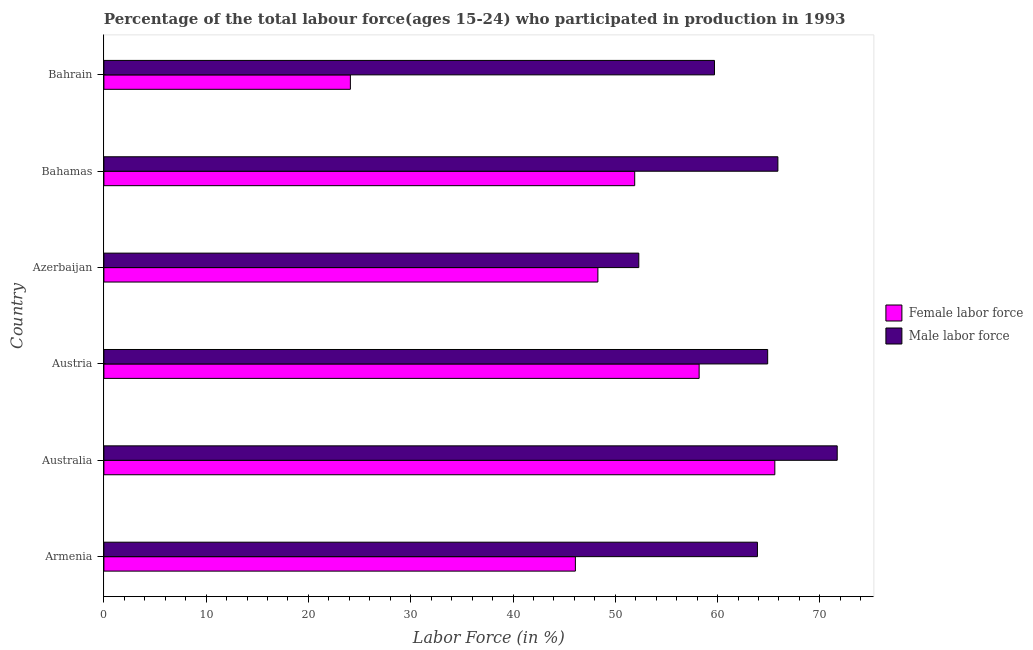How many different coloured bars are there?
Give a very brief answer. 2. What is the label of the 6th group of bars from the top?
Your answer should be compact. Armenia. In how many cases, is the number of bars for a given country not equal to the number of legend labels?
Your answer should be compact. 0. What is the percentage of female labor force in Armenia?
Give a very brief answer. 46.1. Across all countries, what is the maximum percentage of female labor force?
Make the answer very short. 65.6. Across all countries, what is the minimum percentage of male labour force?
Your response must be concise. 52.3. In which country was the percentage of male labour force minimum?
Offer a very short reply. Azerbaijan. What is the total percentage of female labor force in the graph?
Provide a short and direct response. 294.2. What is the difference between the percentage of male labour force in Australia and the percentage of female labor force in Bahrain?
Your answer should be compact. 47.6. What is the average percentage of female labor force per country?
Offer a terse response. 49.03. What is the difference between the percentage of female labor force and percentage of male labour force in Bahrain?
Make the answer very short. -35.6. What is the ratio of the percentage of male labour force in Austria to that in Azerbaijan?
Offer a terse response. 1.24. What is the difference between the highest and the second highest percentage of male labour force?
Provide a succinct answer. 5.8. What is the difference between the highest and the lowest percentage of male labour force?
Provide a succinct answer. 19.4. Is the sum of the percentage of female labor force in Bahamas and Bahrain greater than the maximum percentage of male labour force across all countries?
Give a very brief answer. Yes. What does the 1st bar from the top in Bahamas represents?
Ensure brevity in your answer.  Male labor force. What does the 1st bar from the bottom in Azerbaijan represents?
Ensure brevity in your answer.  Female labor force. How many bars are there?
Your answer should be compact. 12. How many countries are there in the graph?
Your response must be concise. 6. What is the difference between two consecutive major ticks on the X-axis?
Your response must be concise. 10. Does the graph contain any zero values?
Keep it short and to the point. No. Where does the legend appear in the graph?
Ensure brevity in your answer.  Center right. How many legend labels are there?
Your response must be concise. 2. What is the title of the graph?
Ensure brevity in your answer.  Percentage of the total labour force(ages 15-24) who participated in production in 1993. What is the label or title of the X-axis?
Your answer should be compact. Labor Force (in %). What is the Labor Force (in %) of Female labor force in Armenia?
Provide a short and direct response. 46.1. What is the Labor Force (in %) in Male labor force in Armenia?
Give a very brief answer. 63.9. What is the Labor Force (in %) of Female labor force in Australia?
Provide a short and direct response. 65.6. What is the Labor Force (in %) of Male labor force in Australia?
Your answer should be very brief. 71.7. What is the Labor Force (in %) in Female labor force in Austria?
Keep it short and to the point. 58.2. What is the Labor Force (in %) of Male labor force in Austria?
Keep it short and to the point. 64.9. What is the Labor Force (in %) in Female labor force in Azerbaijan?
Keep it short and to the point. 48.3. What is the Labor Force (in %) in Male labor force in Azerbaijan?
Make the answer very short. 52.3. What is the Labor Force (in %) in Female labor force in Bahamas?
Offer a very short reply. 51.9. What is the Labor Force (in %) of Male labor force in Bahamas?
Give a very brief answer. 65.9. What is the Labor Force (in %) in Female labor force in Bahrain?
Ensure brevity in your answer.  24.1. What is the Labor Force (in %) of Male labor force in Bahrain?
Your answer should be very brief. 59.7. Across all countries, what is the maximum Labor Force (in %) of Female labor force?
Your answer should be compact. 65.6. Across all countries, what is the maximum Labor Force (in %) in Male labor force?
Keep it short and to the point. 71.7. Across all countries, what is the minimum Labor Force (in %) in Female labor force?
Your response must be concise. 24.1. Across all countries, what is the minimum Labor Force (in %) of Male labor force?
Keep it short and to the point. 52.3. What is the total Labor Force (in %) of Female labor force in the graph?
Offer a terse response. 294.2. What is the total Labor Force (in %) of Male labor force in the graph?
Provide a short and direct response. 378.4. What is the difference between the Labor Force (in %) of Female labor force in Armenia and that in Australia?
Make the answer very short. -19.5. What is the difference between the Labor Force (in %) in Male labor force in Armenia and that in Austria?
Your answer should be compact. -1. What is the difference between the Labor Force (in %) in Female labor force in Armenia and that in Azerbaijan?
Give a very brief answer. -2.2. What is the difference between the Labor Force (in %) of Male labor force in Armenia and that in Azerbaijan?
Offer a very short reply. 11.6. What is the difference between the Labor Force (in %) of Female labor force in Armenia and that in Bahrain?
Your answer should be very brief. 22. What is the difference between the Labor Force (in %) of Male labor force in Armenia and that in Bahrain?
Make the answer very short. 4.2. What is the difference between the Labor Force (in %) in Female labor force in Australia and that in Bahamas?
Ensure brevity in your answer.  13.7. What is the difference between the Labor Force (in %) of Female labor force in Australia and that in Bahrain?
Your answer should be very brief. 41.5. What is the difference between the Labor Force (in %) of Male labor force in Australia and that in Bahrain?
Your answer should be compact. 12. What is the difference between the Labor Force (in %) in Female labor force in Austria and that in Bahrain?
Offer a terse response. 34.1. What is the difference between the Labor Force (in %) in Male labor force in Austria and that in Bahrain?
Your response must be concise. 5.2. What is the difference between the Labor Force (in %) of Female labor force in Azerbaijan and that in Bahamas?
Your answer should be very brief. -3.6. What is the difference between the Labor Force (in %) in Male labor force in Azerbaijan and that in Bahamas?
Ensure brevity in your answer.  -13.6. What is the difference between the Labor Force (in %) of Female labor force in Azerbaijan and that in Bahrain?
Your answer should be compact. 24.2. What is the difference between the Labor Force (in %) in Female labor force in Bahamas and that in Bahrain?
Your answer should be compact. 27.8. What is the difference between the Labor Force (in %) in Female labor force in Armenia and the Labor Force (in %) in Male labor force in Australia?
Offer a very short reply. -25.6. What is the difference between the Labor Force (in %) in Female labor force in Armenia and the Labor Force (in %) in Male labor force in Austria?
Offer a very short reply. -18.8. What is the difference between the Labor Force (in %) of Female labor force in Armenia and the Labor Force (in %) of Male labor force in Azerbaijan?
Provide a short and direct response. -6.2. What is the difference between the Labor Force (in %) in Female labor force in Armenia and the Labor Force (in %) in Male labor force in Bahamas?
Offer a very short reply. -19.8. What is the difference between the Labor Force (in %) in Female labor force in Australia and the Labor Force (in %) in Male labor force in Austria?
Your answer should be very brief. 0.7. What is the difference between the Labor Force (in %) in Female labor force in Australia and the Labor Force (in %) in Male labor force in Azerbaijan?
Ensure brevity in your answer.  13.3. What is the difference between the Labor Force (in %) in Female labor force in Austria and the Labor Force (in %) in Male labor force in Bahamas?
Offer a very short reply. -7.7. What is the difference between the Labor Force (in %) of Female labor force in Austria and the Labor Force (in %) of Male labor force in Bahrain?
Offer a very short reply. -1.5. What is the difference between the Labor Force (in %) in Female labor force in Azerbaijan and the Labor Force (in %) in Male labor force in Bahamas?
Your response must be concise. -17.6. What is the average Labor Force (in %) in Female labor force per country?
Keep it short and to the point. 49.03. What is the average Labor Force (in %) of Male labor force per country?
Offer a very short reply. 63.07. What is the difference between the Labor Force (in %) in Female labor force and Labor Force (in %) in Male labor force in Armenia?
Ensure brevity in your answer.  -17.8. What is the difference between the Labor Force (in %) of Female labor force and Labor Force (in %) of Male labor force in Austria?
Your answer should be compact. -6.7. What is the difference between the Labor Force (in %) of Female labor force and Labor Force (in %) of Male labor force in Azerbaijan?
Give a very brief answer. -4. What is the difference between the Labor Force (in %) in Female labor force and Labor Force (in %) in Male labor force in Bahamas?
Offer a very short reply. -14. What is the difference between the Labor Force (in %) of Female labor force and Labor Force (in %) of Male labor force in Bahrain?
Keep it short and to the point. -35.6. What is the ratio of the Labor Force (in %) in Female labor force in Armenia to that in Australia?
Offer a very short reply. 0.7. What is the ratio of the Labor Force (in %) of Male labor force in Armenia to that in Australia?
Keep it short and to the point. 0.89. What is the ratio of the Labor Force (in %) of Female labor force in Armenia to that in Austria?
Offer a very short reply. 0.79. What is the ratio of the Labor Force (in %) in Male labor force in Armenia to that in Austria?
Provide a short and direct response. 0.98. What is the ratio of the Labor Force (in %) of Female labor force in Armenia to that in Azerbaijan?
Make the answer very short. 0.95. What is the ratio of the Labor Force (in %) of Male labor force in Armenia to that in Azerbaijan?
Your answer should be very brief. 1.22. What is the ratio of the Labor Force (in %) of Female labor force in Armenia to that in Bahamas?
Give a very brief answer. 0.89. What is the ratio of the Labor Force (in %) in Male labor force in Armenia to that in Bahamas?
Keep it short and to the point. 0.97. What is the ratio of the Labor Force (in %) of Female labor force in Armenia to that in Bahrain?
Your answer should be very brief. 1.91. What is the ratio of the Labor Force (in %) of Male labor force in Armenia to that in Bahrain?
Your answer should be compact. 1.07. What is the ratio of the Labor Force (in %) of Female labor force in Australia to that in Austria?
Offer a very short reply. 1.13. What is the ratio of the Labor Force (in %) of Male labor force in Australia to that in Austria?
Offer a very short reply. 1.1. What is the ratio of the Labor Force (in %) in Female labor force in Australia to that in Azerbaijan?
Offer a very short reply. 1.36. What is the ratio of the Labor Force (in %) in Male labor force in Australia to that in Azerbaijan?
Keep it short and to the point. 1.37. What is the ratio of the Labor Force (in %) of Female labor force in Australia to that in Bahamas?
Give a very brief answer. 1.26. What is the ratio of the Labor Force (in %) of Male labor force in Australia to that in Bahamas?
Make the answer very short. 1.09. What is the ratio of the Labor Force (in %) of Female labor force in Australia to that in Bahrain?
Offer a terse response. 2.72. What is the ratio of the Labor Force (in %) in Male labor force in Australia to that in Bahrain?
Your response must be concise. 1.2. What is the ratio of the Labor Force (in %) of Female labor force in Austria to that in Azerbaijan?
Provide a succinct answer. 1.21. What is the ratio of the Labor Force (in %) of Male labor force in Austria to that in Azerbaijan?
Your answer should be very brief. 1.24. What is the ratio of the Labor Force (in %) of Female labor force in Austria to that in Bahamas?
Your answer should be very brief. 1.12. What is the ratio of the Labor Force (in %) in Female labor force in Austria to that in Bahrain?
Your answer should be very brief. 2.41. What is the ratio of the Labor Force (in %) of Male labor force in Austria to that in Bahrain?
Provide a short and direct response. 1.09. What is the ratio of the Labor Force (in %) in Female labor force in Azerbaijan to that in Bahamas?
Your response must be concise. 0.93. What is the ratio of the Labor Force (in %) of Male labor force in Azerbaijan to that in Bahamas?
Keep it short and to the point. 0.79. What is the ratio of the Labor Force (in %) of Female labor force in Azerbaijan to that in Bahrain?
Give a very brief answer. 2. What is the ratio of the Labor Force (in %) of Male labor force in Azerbaijan to that in Bahrain?
Give a very brief answer. 0.88. What is the ratio of the Labor Force (in %) of Female labor force in Bahamas to that in Bahrain?
Provide a succinct answer. 2.15. What is the ratio of the Labor Force (in %) in Male labor force in Bahamas to that in Bahrain?
Offer a terse response. 1.1. What is the difference between the highest and the lowest Labor Force (in %) in Female labor force?
Provide a short and direct response. 41.5. What is the difference between the highest and the lowest Labor Force (in %) of Male labor force?
Offer a terse response. 19.4. 